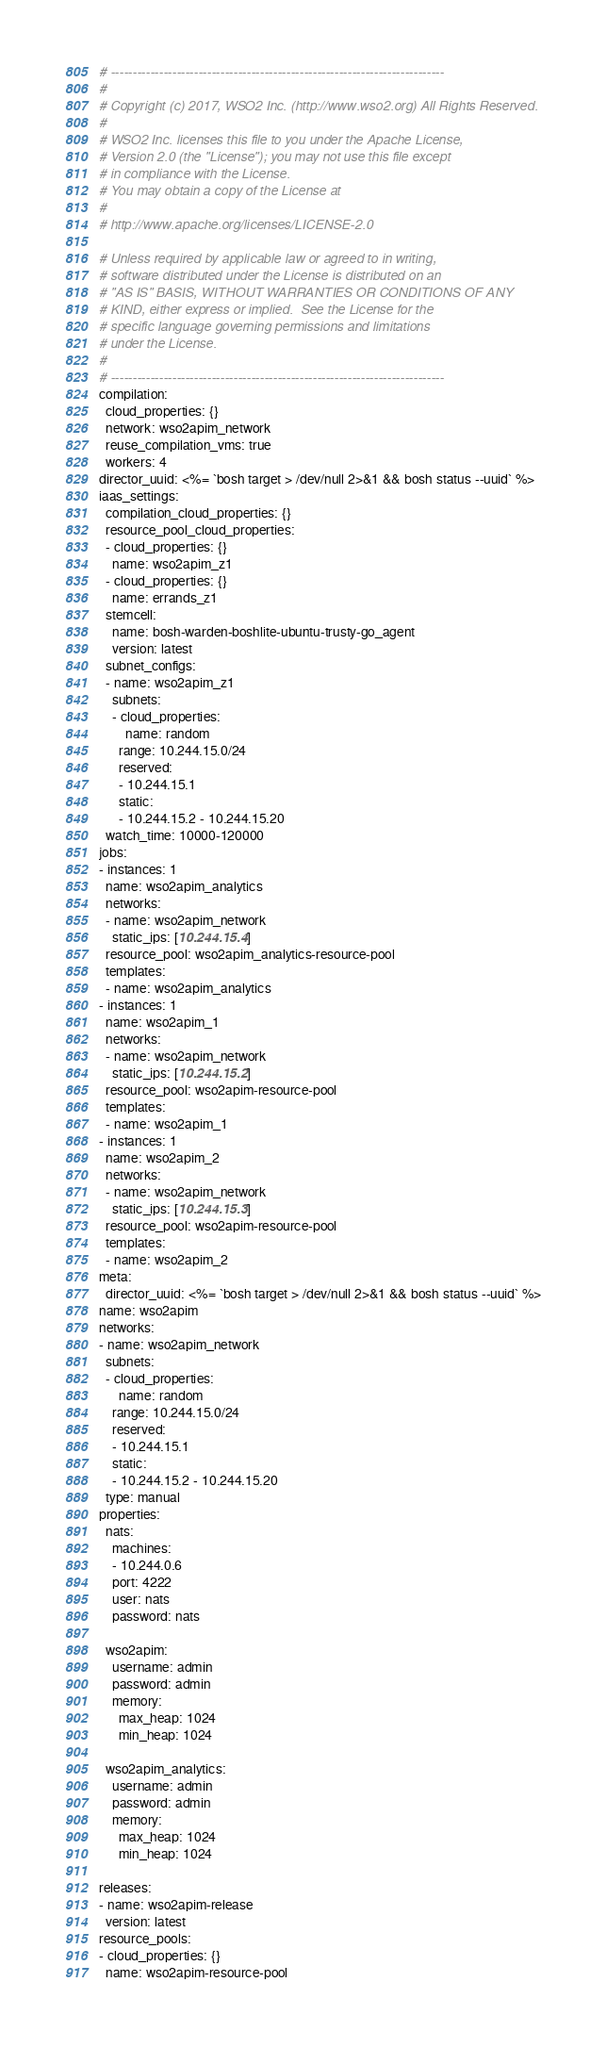Convert code to text. <code><loc_0><loc_0><loc_500><loc_500><_YAML_># ----------------------------------------------------------------------------
#
# Copyright (c) 2017, WSO2 Inc. (http://www.wso2.org) All Rights Reserved.
#
# WSO2 Inc. licenses this file to you under the Apache License,
# Version 2.0 (the "License"); you may not use this file except
# in compliance with the License.
# You may obtain a copy of the License at
#
# http://www.apache.org/licenses/LICENSE-2.0

# Unless required by applicable law or agreed to in writing,
# software distributed under the License is distributed on an
# "AS IS" BASIS, WITHOUT WARRANTIES OR CONDITIONS OF ANY
# KIND, either express or implied.  See the License for the
# specific language governing permissions and limitations
# under the License.
#
# ----------------------------------------------------------------------------
compilation:
  cloud_properties: {}
  network: wso2apim_network
  reuse_compilation_vms: true
  workers: 4
director_uuid: <%= `bosh target > /dev/null 2>&1 && bosh status --uuid` %>
iaas_settings:
  compilation_cloud_properties: {}
  resource_pool_cloud_properties:
  - cloud_properties: {}
    name: wso2apim_z1
  - cloud_properties: {}
    name: errands_z1
  stemcell:
    name: bosh-warden-boshlite-ubuntu-trusty-go_agent
    version: latest
  subnet_configs:
  - name: wso2apim_z1
    subnets:
    - cloud_properties:
        name: random
      range: 10.244.15.0/24
      reserved:
      - 10.244.15.1
      static:
      - 10.244.15.2 - 10.244.15.20
  watch_time: 10000-120000
jobs:
- instances: 1
  name: wso2apim_analytics
  networks:
  - name: wso2apim_network
    static_ips: [10.244.15.4]
  resource_pool: wso2apim_analytics-resource-pool
  templates:
  - name: wso2apim_analytics
- instances: 1
  name: wso2apim_1
  networks:
  - name: wso2apim_network
    static_ips: [10.244.15.2]
  resource_pool: wso2apim-resource-pool
  templates:
  - name: wso2apim_1
- instances: 1
  name: wso2apim_2
  networks:
  - name: wso2apim_network
    static_ips: [10.244.15.3]
  resource_pool: wso2apim-resource-pool
  templates:
  - name: wso2apim_2
meta:
  director_uuid: <%= `bosh target > /dev/null 2>&1 && bosh status --uuid` %>
name: wso2apim
networks:
- name: wso2apim_network
  subnets:
  - cloud_properties:
      name: random
    range: 10.244.15.0/24
    reserved:
    - 10.244.15.1
    static:
    - 10.244.15.2 - 10.244.15.20
  type: manual
properties:
  nats:
    machines:
    - 10.244.0.6
    port: 4222
    user: nats
    password: nats

  wso2apim:
    username: admin
    password: admin
    memory:
      max_heap: 1024
      min_heap: 1024

  wso2apim_analytics:
    username: admin
    password: admin
    memory:
      max_heap: 1024
      min_heap: 1024

releases:
- name: wso2apim-release
  version: latest
resource_pools:
- cloud_properties: {}
  name: wso2apim-resource-pool</code> 